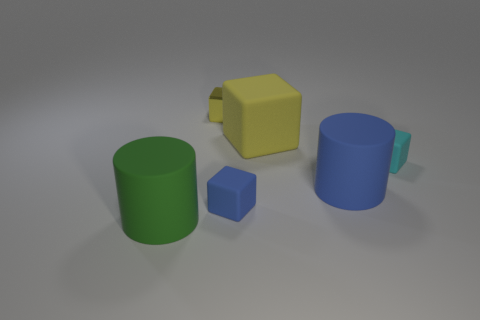Subtract all purple spheres. How many yellow cubes are left? 2 Subtract all cyan blocks. How many blocks are left? 3 Subtract all large yellow blocks. How many blocks are left? 3 Subtract all purple cubes. Subtract all purple balls. How many cubes are left? 4 Add 1 cyan objects. How many objects exist? 7 Subtract all cylinders. How many objects are left? 4 Subtract all tiny cubes. Subtract all big blue rubber objects. How many objects are left? 2 Add 5 blue cylinders. How many blue cylinders are left? 6 Add 4 small purple shiny balls. How many small purple shiny balls exist? 4 Subtract 0 yellow cylinders. How many objects are left? 6 